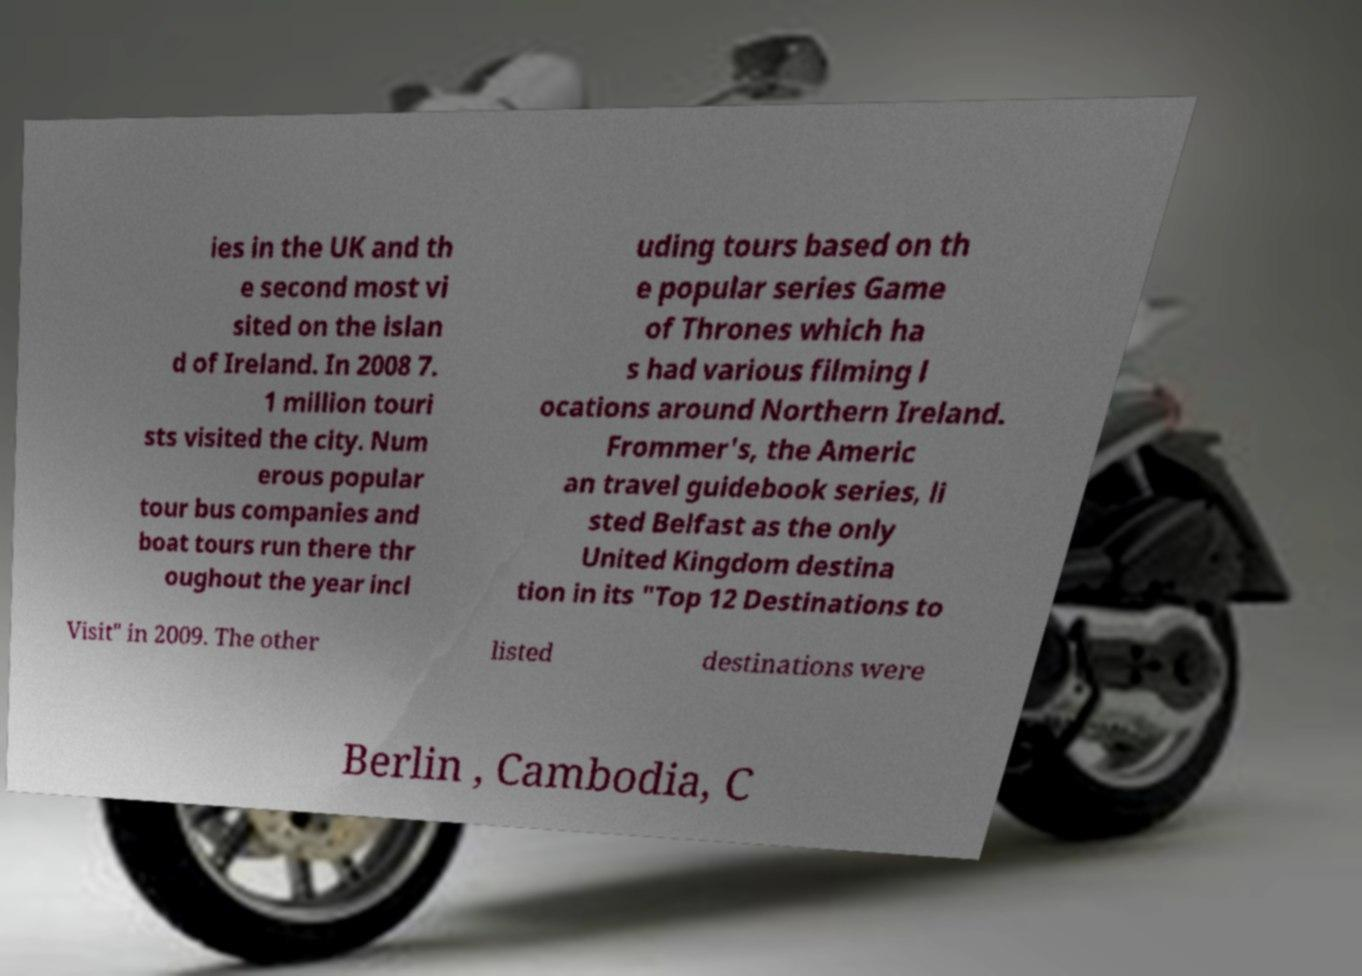I need the written content from this picture converted into text. Can you do that? ies in the UK and th e second most vi sited on the islan d of Ireland. In 2008 7. 1 million touri sts visited the city. Num erous popular tour bus companies and boat tours run there thr oughout the year incl uding tours based on th e popular series Game of Thrones which ha s had various filming l ocations around Northern Ireland. Frommer's, the Americ an travel guidebook series, li sted Belfast as the only United Kingdom destina tion in its "Top 12 Destinations to Visit" in 2009. The other listed destinations were Berlin , Cambodia, C 